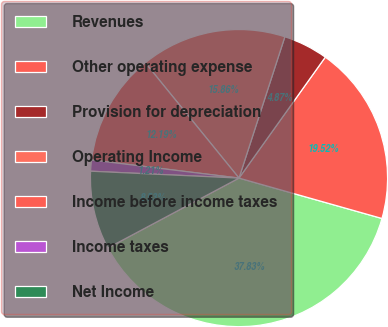Convert chart to OTSL. <chart><loc_0><loc_0><loc_500><loc_500><pie_chart><fcel>Revenues<fcel>Other operating expense<fcel>Provision for depreciation<fcel>Operating Income<fcel>Income before income taxes<fcel>Income taxes<fcel>Net Income<nl><fcel>37.83%<fcel>19.52%<fcel>4.87%<fcel>15.86%<fcel>12.19%<fcel>1.21%<fcel>8.53%<nl></chart> 